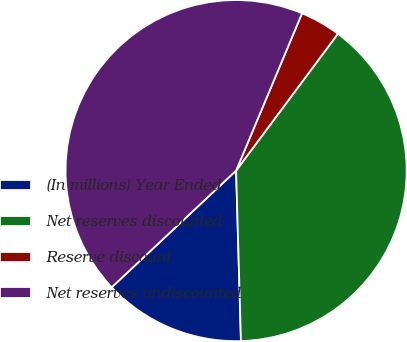Convert chart. <chart><loc_0><loc_0><loc_500><loc_500><pie_chart><fcel>(In millions) Year Ended<fcel>Net reserves discounted<fcel>Reserve discount<fcel>Net reserves undiscounted<nl><fcel>13.46%<fcel>39.37%<fcel>3.86%<fcel>43.31%<nl></chart> 